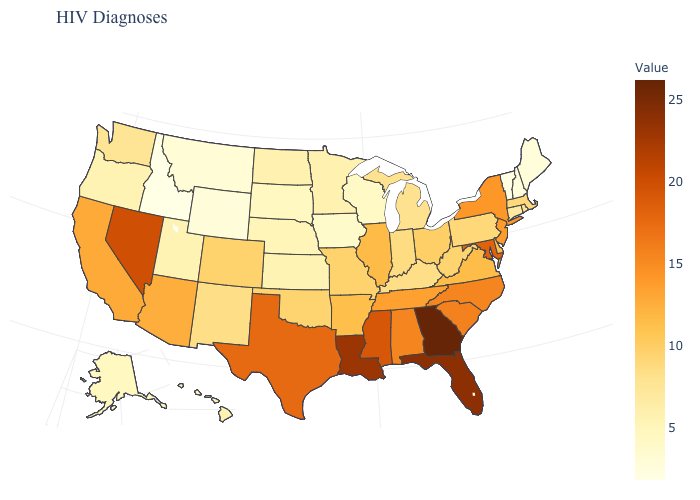Among the states that border South Carolina , which have the lowest value?
Be succinct. North Carolina. Does Mississippi have the highest value in the South?
Concise answer only. No. Which states have the highest value in the USA?
Quick response, please. Georgia. 